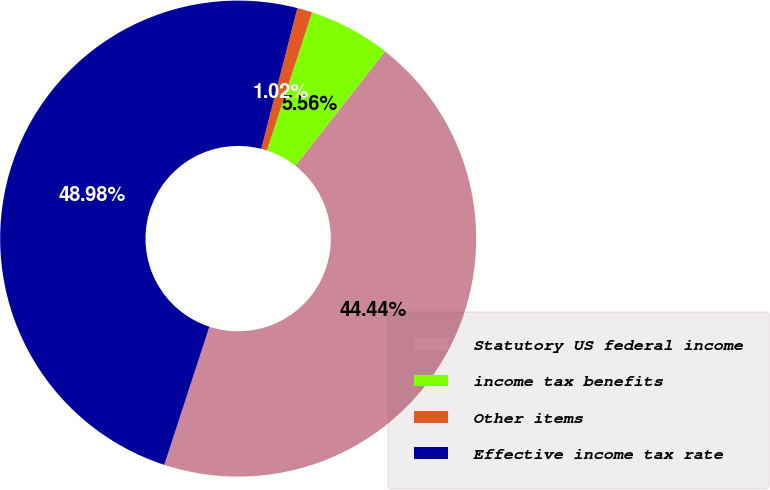Convert chart to OTSL. <chart><loc_0><loc_0><loc_500><loc_500><pie_chart><fcel>Statutory US federal income<fcel>income tax benefits<fcel>Other items<fcel>Effective income tax rate<nl><fcel>44.44%<fcel>5.56%<fcel>1.02%<fcel>48.98%<nl></chart> 